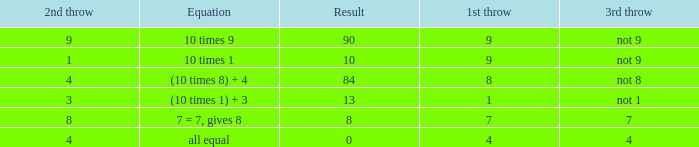Parse the table in full. {'header': ['2nd throw', 'Equation', 'Result', '1st throw', '3rd throw'], 'rows': [['9', '10 times 9', '90', '9', 'not 9'], ['1', '10 times 1', '10', '9', 'not 9'], ['4', '(10 times 8) + 4', '84', '8', 'not 8'], ['3', '(10 times 1) + 3', '13', '1', 'not 1'], ['8', '7 = 7, gives 8', '8', '7', '7'], ['4', 'all equal', '0', '4', '4']]} If the equation is all equal, what is the 3rd throw? 4.0. 